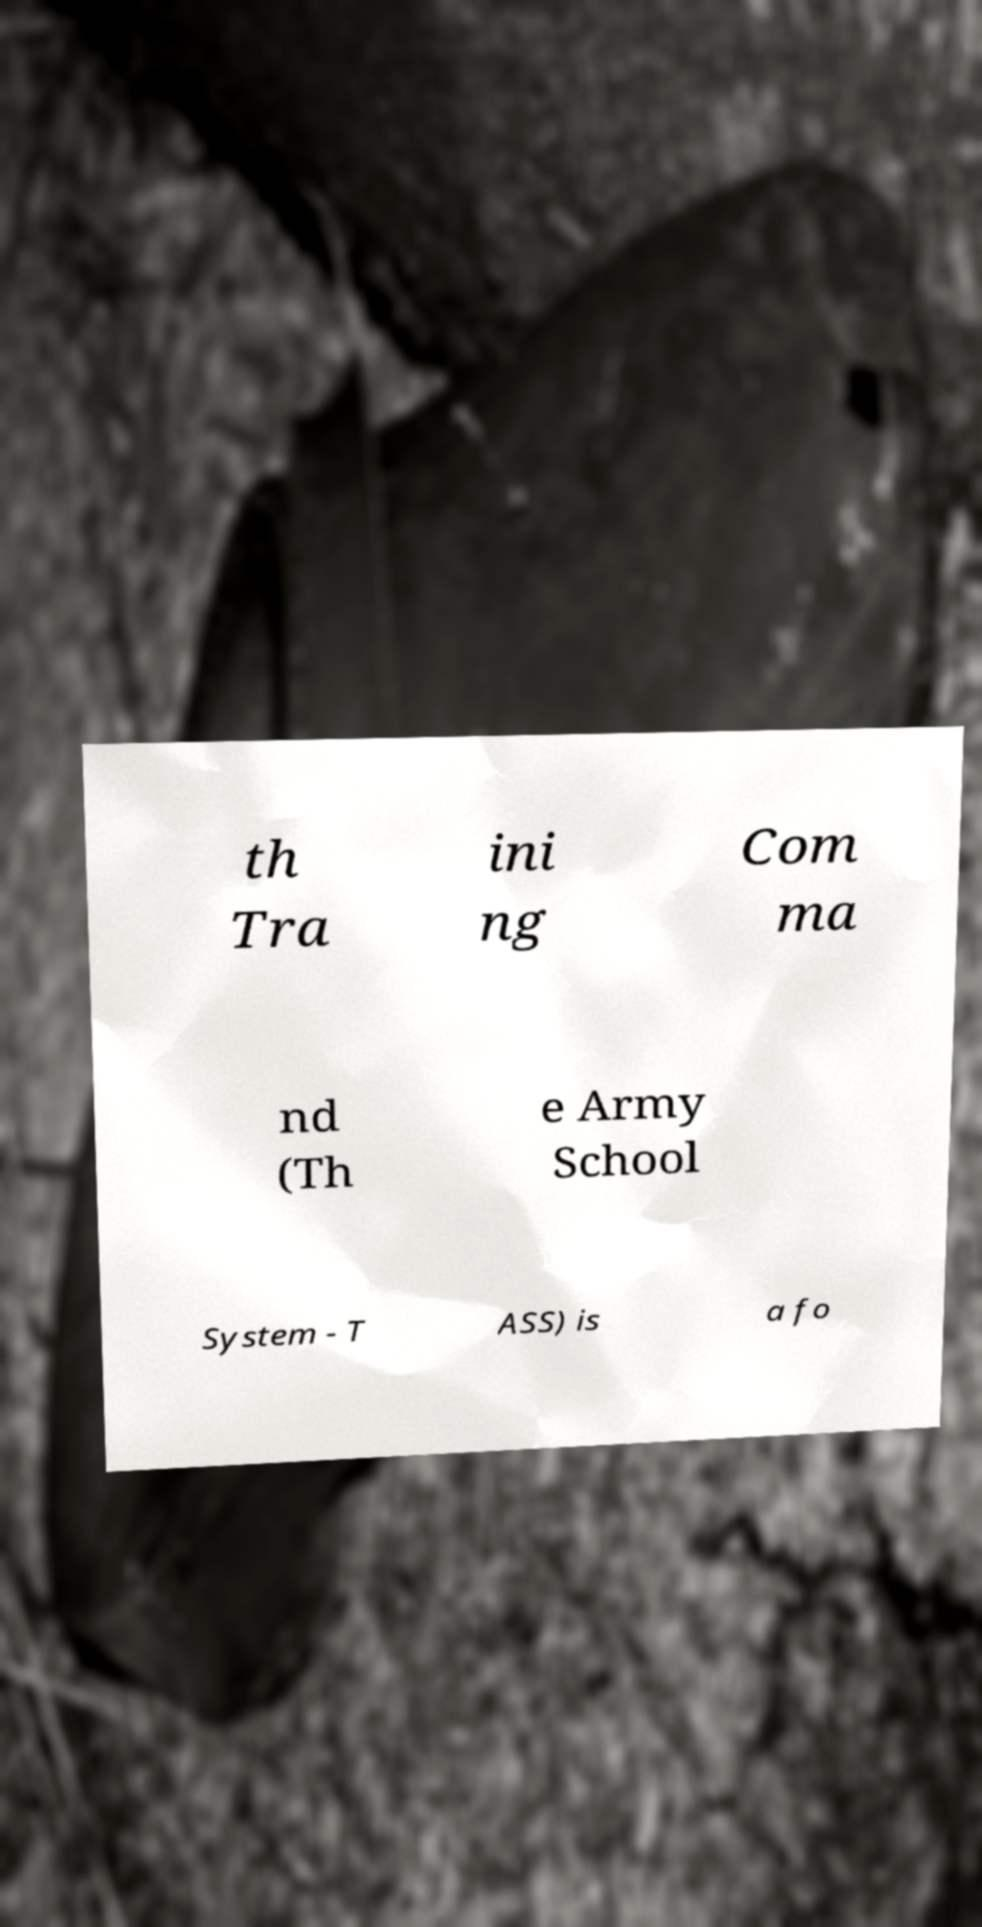There's text embedded in this image that I need extracted. Can you transcribe it verbatim? th Tra ini ng Com ma nd (Th e Army School System - T ASS) is a fo 